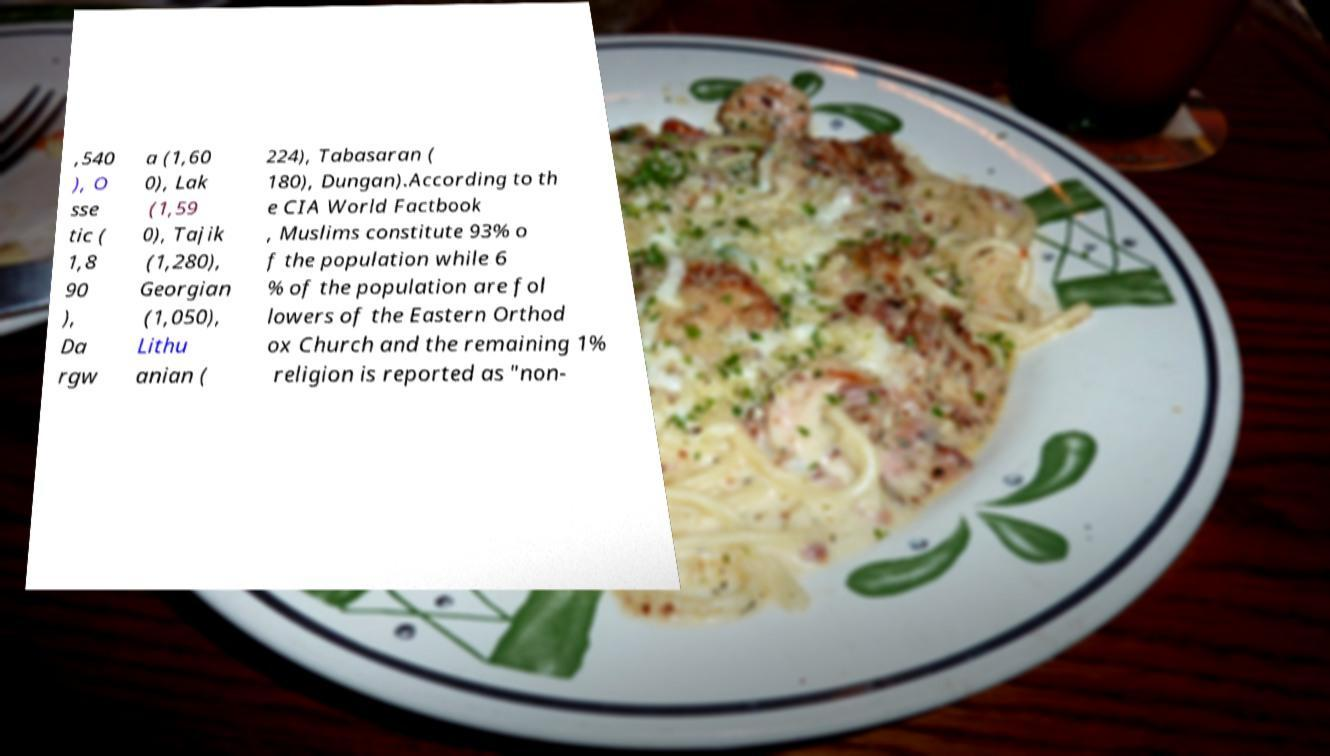I need the written content from this picture converted into text. Can you do that? ,540 ), O sse tic ( 1,8 90 ), Da rgw a (1,60 0), Lak (1,59 0), Tajik (1,280), Georgian (1,050), Lithu anian ( 224), Tabasaran ( 180), Dungan).According to th e CIA World Factbook , Muslims constitute 93% o f the population while 6 % of the population are fol lowers of the Eastern Orthod ox Church and the remaining 1% religion is reported as "non- 